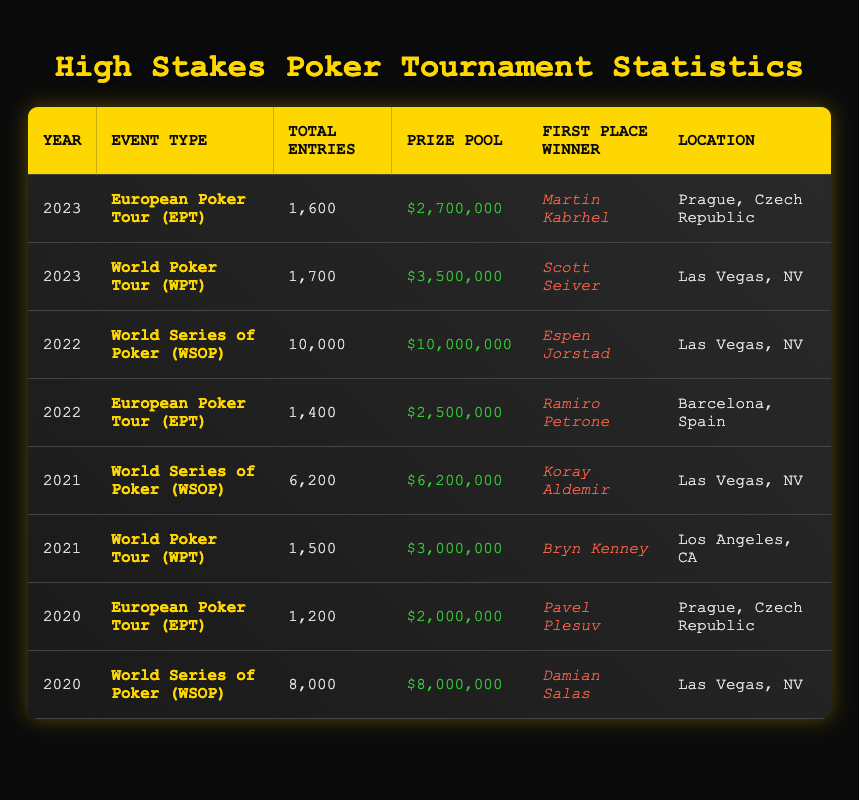What was the prize pool for the World Series of Poker in 2022? From the table, we can locate the row for the World Series of Poker (WSOP) event in 2022, which shows a prize pool of $10,000,000.
Answer: $10,000,000 Who won the European Poker Tour in 2023? Looking at the table, I can find the row for the European Poker Tour (EPT) in 2023, where Martin Kabrhel is listed as the first place winner.
Answer: Martin Kabrhel How many total entries were there in the World Poker Tour events from 2020 to 2023 combined? To find the total entries for World Poker Tour events from 2020 to 2023, we only need to look at the rows corresponding to WPT across these years: 0 for 2020 (no event listed), 1500 for 2021, 1700 for 2023. (So, 0 + 1500 + 1700 = 3200.) Therefore, the total entries are 3200.
Answer: 3200 Was the total prize pool higher in 2021 for any event compared to 2020? First, I locate the total prize pools for each year: 2020 has $8,000,000 for WSOP and $2,000,000 for EPT; 2021 has $3,000,000 for WPT and $6,200,000 for WSOP. Thus, in 2021, the highest prize pool is $6,200,000, which is lower than $8,000,000 from 2020 (WSOP). Hence, the answer is no.
Answer: No What event had the most total entries in 2022? In 2022, I see two events: the World Series of Poker with 10,000 entries and the European Poker Tour with 1,400 entries. Clearly, the WSOP event has more entries, totaling 10,000. Therefore, it had the most total entries in 2022.
Answer: World Series of Poker (WSOP) Was the location of the European Poker Tour in 2020 the same as in 2021? Checking the table, the location for EPT in 2020 is Prague, Czech Republic, while for 2021 (not listed, so no event that year). Since there is no 2021 EPT event, we cannot compare, so the answer is no.
Answer: No In which year did the World Poker Tour event have more entries than its previous event? The WPT event in 2021 had 1,500 entries and in 2023 that had 1,700. Thus, 2023's entry total (1,700) is greater than 2021's total (1,500). So, the WPT had more entries in 2023 compared to 2021.
Answer: 2023 What was the location of the first place winner for the World Poker Tour in 2021? For the World Poker Tour event in 2021, the location listed in the table is Los Angeles, CA, where Bryn Kenney was the winner.
Answer: Los Angeles, CA How much did the prize pool increase from the European Poker Tour in 2022 compared to 2021? The EPT in 2022 had a prize pool of $2,500,000 while the 2021 EPT prize pool is not available (no event for 2021). Therefore, it cannot be compared with 2021 for this increase.
Answer: Cannot determine 